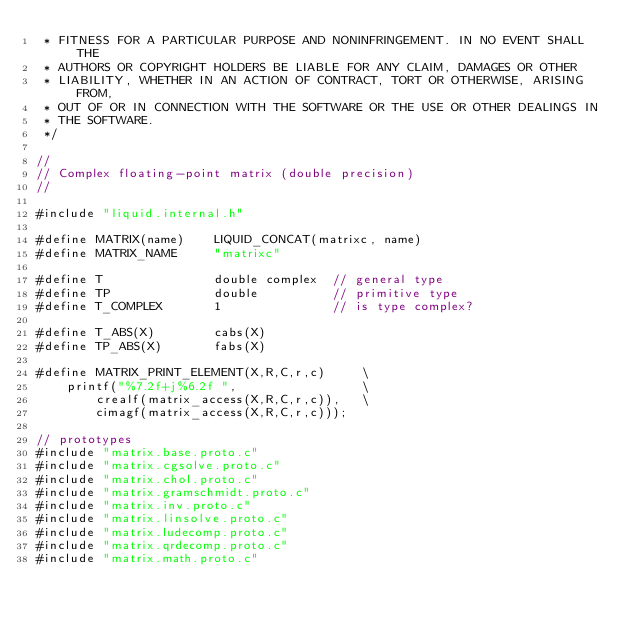Convert code to text. <code><loc_0><loc_0><loc_500><loc_500><_C_> * FITNESS FOR A PARTICULAR PURPOSE AND NONINFRINGEMENT. IN NO EVENT SHALL THE
 * AUTHORS OR COPYRIGHT HOLDERS BE LIABLE FOR ANY CLAIM, DAMAGES OR OTHER
 * LIABILITY, WHETHER IN AN ACTION OF CONTRACT, TORT OR OTHERWISE, ARISING FROM,
 * OUT OF OR IN CONNECTION WITH THE SOFTWARE OR THE USE OR OTHER DEALINGS IN
 * THE SOFTWARE.
 */

//
// Complex floating-point matrix (double precision)
// 

#include "liquid.internal.h"

#define MATRIX(name)    LIQUID_CONCAT(matrixc, name)
#define MATRIX_NAME     "matrixc"

#define T               double complex  // general type
#define TP              double          // primitive type
#define T_COMPLEX       1               // is type complex?

#define T_ABS(X)        cabs(X)
#define TP_ABS(X)       fabs(X)

#define MATRIX_PRINT_ELEMENT(X,R,C,r,c)     \
    printf("%7.2f+j%6.2f ",                 \
        crealf(matrix_access(X,R,C,r,c)),   \
        cimagf(matrix_access(X,R,C,r,c)));

// prototypes
#include "matrix.base.proto.c"
#include "matrix.cgsolve.proto.c"
#include "matrix.chol.proto.c"
#include "matrix.gramschmidt.proto.c"
#include "matrix.inv.proto.c"
#include "matrix.linsolve.proto.c"
#include "matrix.ludecomp.proto.c"
#include "matrix.qrdecomp.proto.c"
#include "matrix.math.proto.c"

</code> 